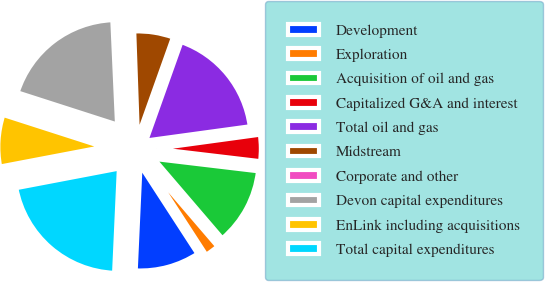Convert chart to OTSL. <chart><loc_0><loc_0><loc_500><loc_500><pie_chart><fcel>Development<fcel>Exploration<fcel>Acquisition of oil and gas<fcel>Capitalized G&A and interest<fcel>Total oil and gas<fcel>Midstream<fcel>Corporate and other<fcel>Devon capital expenditures<fcel>EnLink including acquisitions<fcel>Total capital expenditures<nl><fcel>9.89%<fcel>2.11%<fcel>11.84%<fcel>4.05%<fcel>17.39%<fcel>6.0%<fcel>0.16%<fcel>19.33%<fcel>7.95%<fcel>21.28%<nl></chart> 